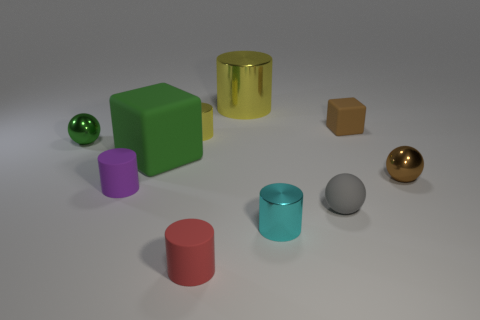Are there any other things that have the same color as the rubber ball?
Your answer should be compact. No. What material is the yellow cylinder in front of the block on the right side of the metallic cylinder in front of the tiny gray ball made of?
Give a very brief answer. Metal. What material is the cylinder behind the small cylinder behind the green metal sphere?
Give a very brief answer. Metal. There is a shiny cylinder to the right of the big yellow metallic cylinder; is its size the same as the matte cylinder behind the gray rubber object?
Your answer should be very brief. Yes. What number of big things are purple rubber cylinders or gray rubber blocks?
Offer a very short reply. 0. How many objects are rubber cylinders on the left side of the tiny red rubber cylinder or large yellow cylinders?
Make the answer very short. 2. What number of other things are there of the same shape as the small red thing?
Ensure brevity in your answer.  4. How many brown objects are rubber spheres or blocks?
Your answer should be very brief. 1. There is another small cylinder that is the same material as the small yellow cylinder; what color is it?
Ensure brevity in your answer.  Cyan. Are the brown object that is behind the tiny green shiny thing and the yellow thing on the left side of the big metallic object made of the same material?
Your response must be concise. No. 